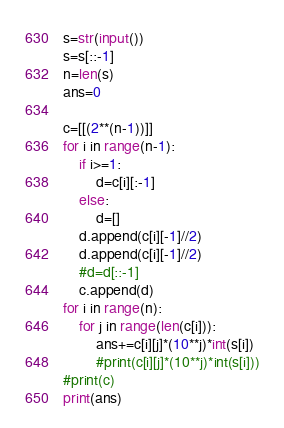<code> <loc_0><loc_0><loc_500><loc_500><_Python_>s=str(input())
s=s[::-1]
n=len(s)
ans=0

c=[[(2**(n-1))]]
for i in range(n-1):
    if i>=1:
        d=c[i][:-1]
    else:
        d=[]
    d.append(c[i][-1]//2)
    d.append(c[i][-1]//2)
    #d=d[::-1]
    c.append(d)
for i in range(n):
    for j in range(len(c[i])):
        ans+=c[i][j]*(10**j)*int(s[i])
        #print(c[i][j]*(10**j)*int(s[i]))
#print(c)
print(ans)</code> 